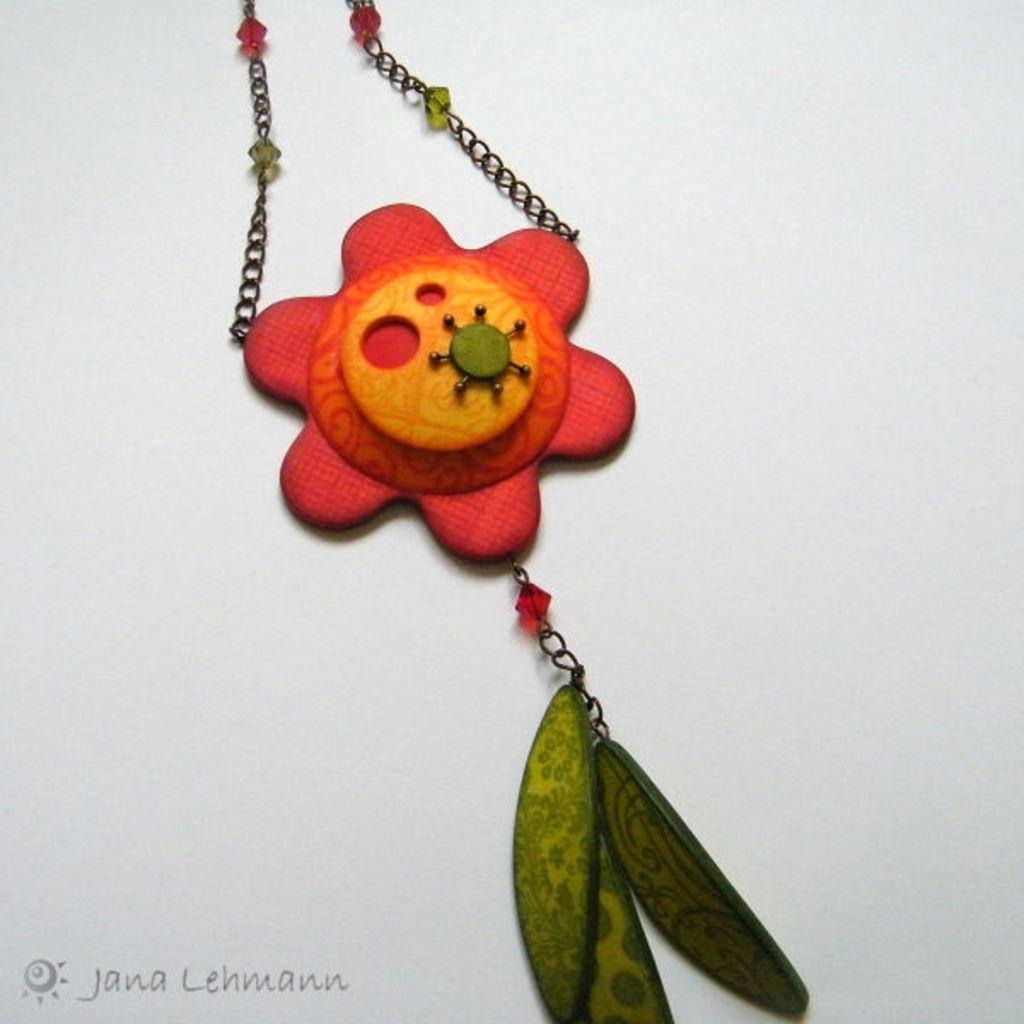What is present on the floor in the image? There is a chain with a locket on the floor. Can you describe the chain in the image? The chain has a locket attached to it. How is the chain and locket positioned in the image? The chain and locket are on the floor. What type of boot is visible in the image? There is no boot present in the image; it only features a chain with a locket on the floor. How does the throat look in the image? There is no reference to a throat in the image, as it only contains a chain with a locket on the floor. 